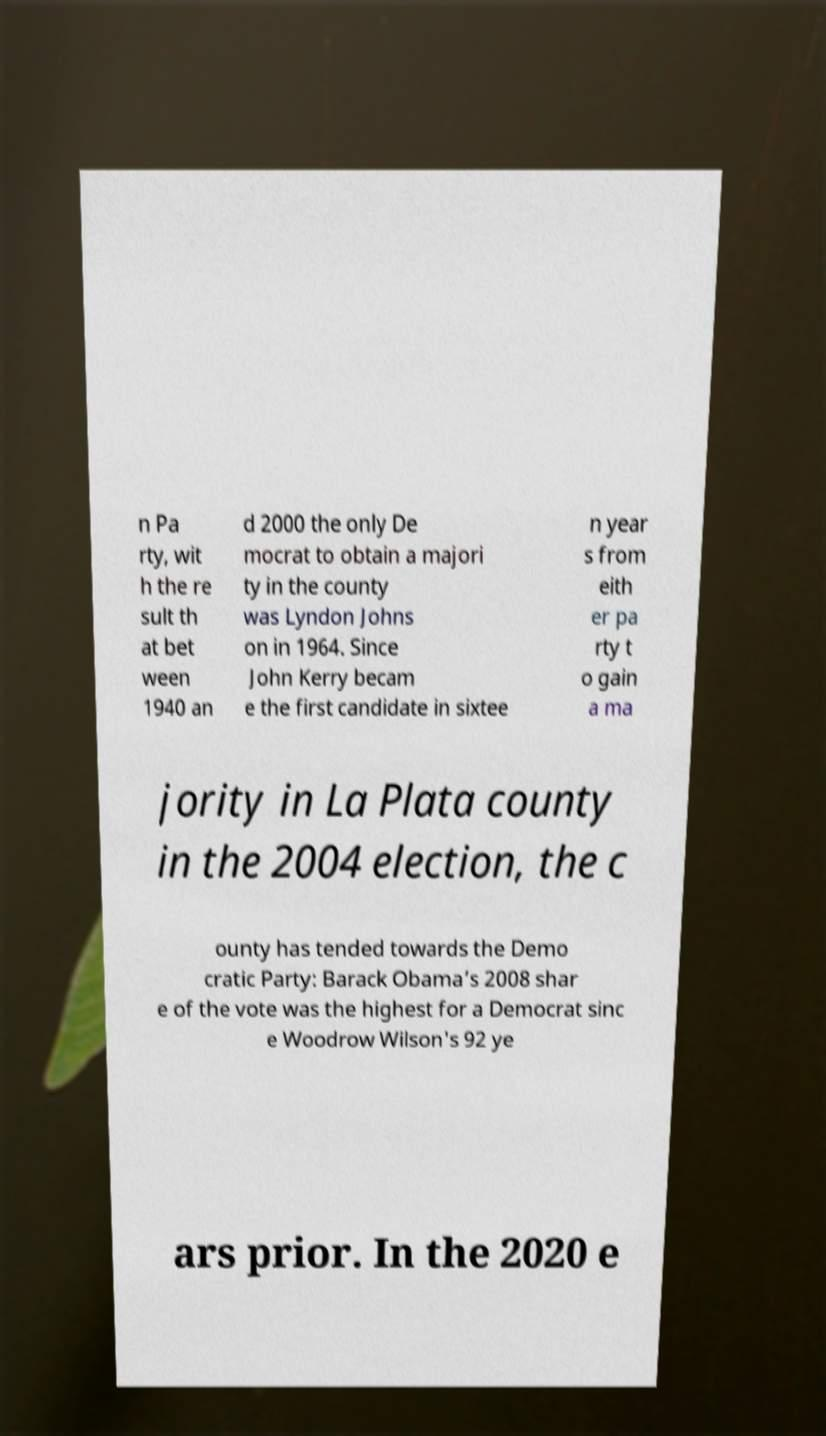What messages or text are displayed in this image? I need them in a readable, typed format. n Pa rty, wit h the re sult th at bet ween 1940 an d 2000 the only De mocrat to obtain a majori ty in the county was Lyndon Johns on in 1964. Since John Kerry becam e the first candidate in sixtee n year s from eith er pa rty t o gain a ma jority in La Plata county in the 2004 election, the c ounty has tended towards the Demo cratic Party: Barack Obama’s 2008 shar e of the vote was the highest for a Democrat sinc e Woodrow Wilson's 92 ye ars prior. In the 2020 e 